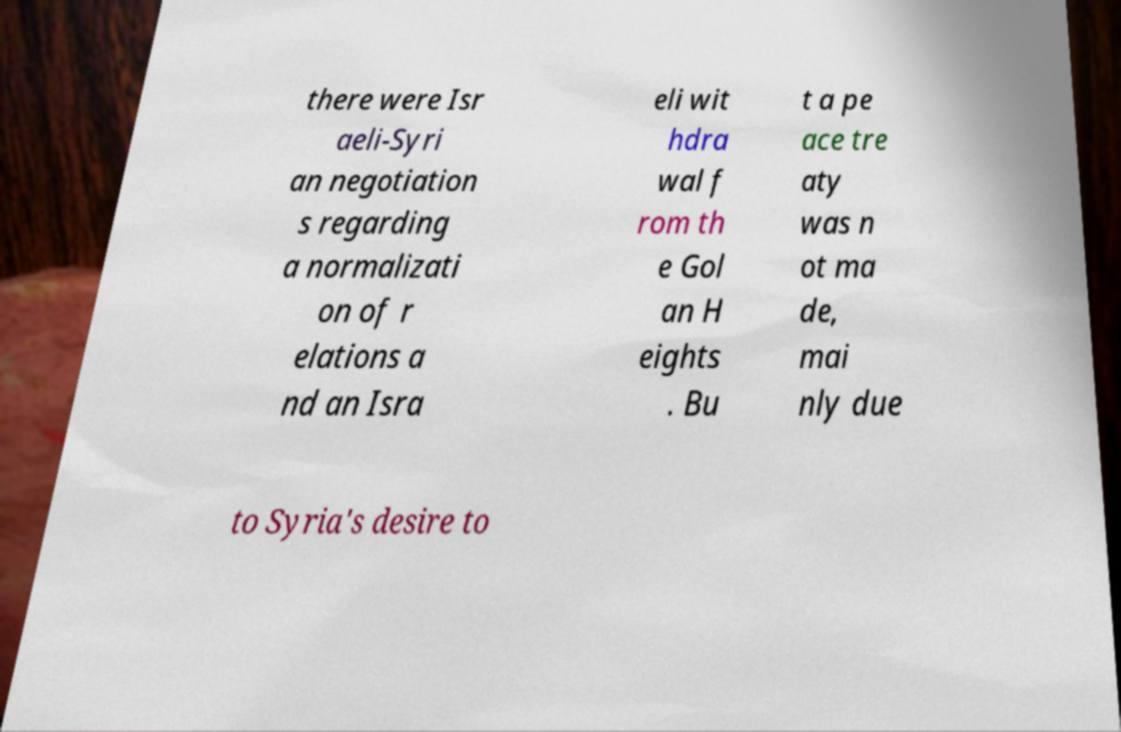Can you read and provide the text displayed in the image?This photo seems to have some interesting text. Can you extract and type it out for me? there were Isr aeli-Syri an negotiation s regarding a normalizati on of r elations a nd an Isra eli wit hdra wal f rom th e Gol an H eights . Bu t a pe ace tre aty was n ot ma de, mai nly due to Syria's desire to 